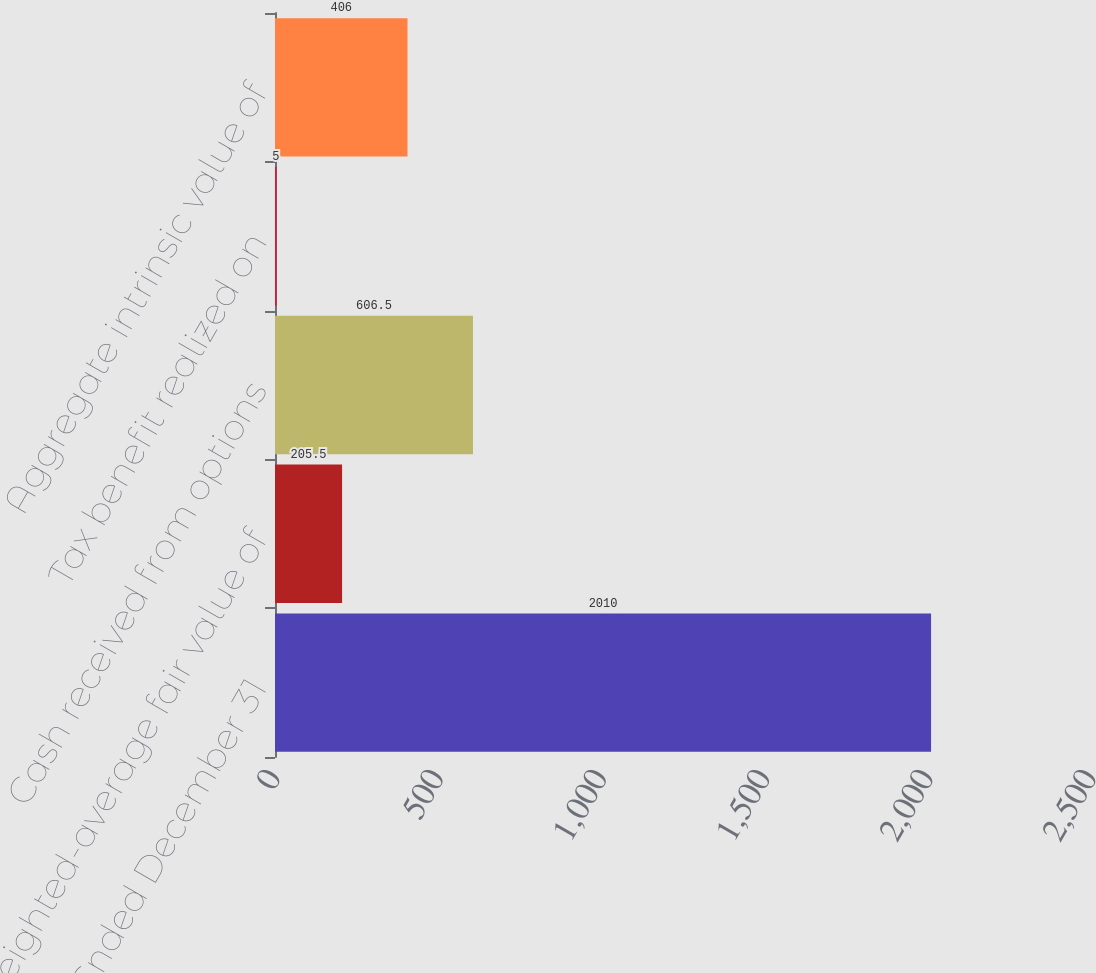Convert chart. <chart><loc_0><loc_0><loc_500><loc_500><bar_chart><fcel>Year Ended December 31<fcel>Weighted-average fair value of<fcel>Cash received from options<fcel>Tax benefit realized on<fcel>Aggregate intrinsic value of<nl><fcel>2010<fcel>205.5<fcel>606.5<fcel>5<fcel>406<nl></chart> 